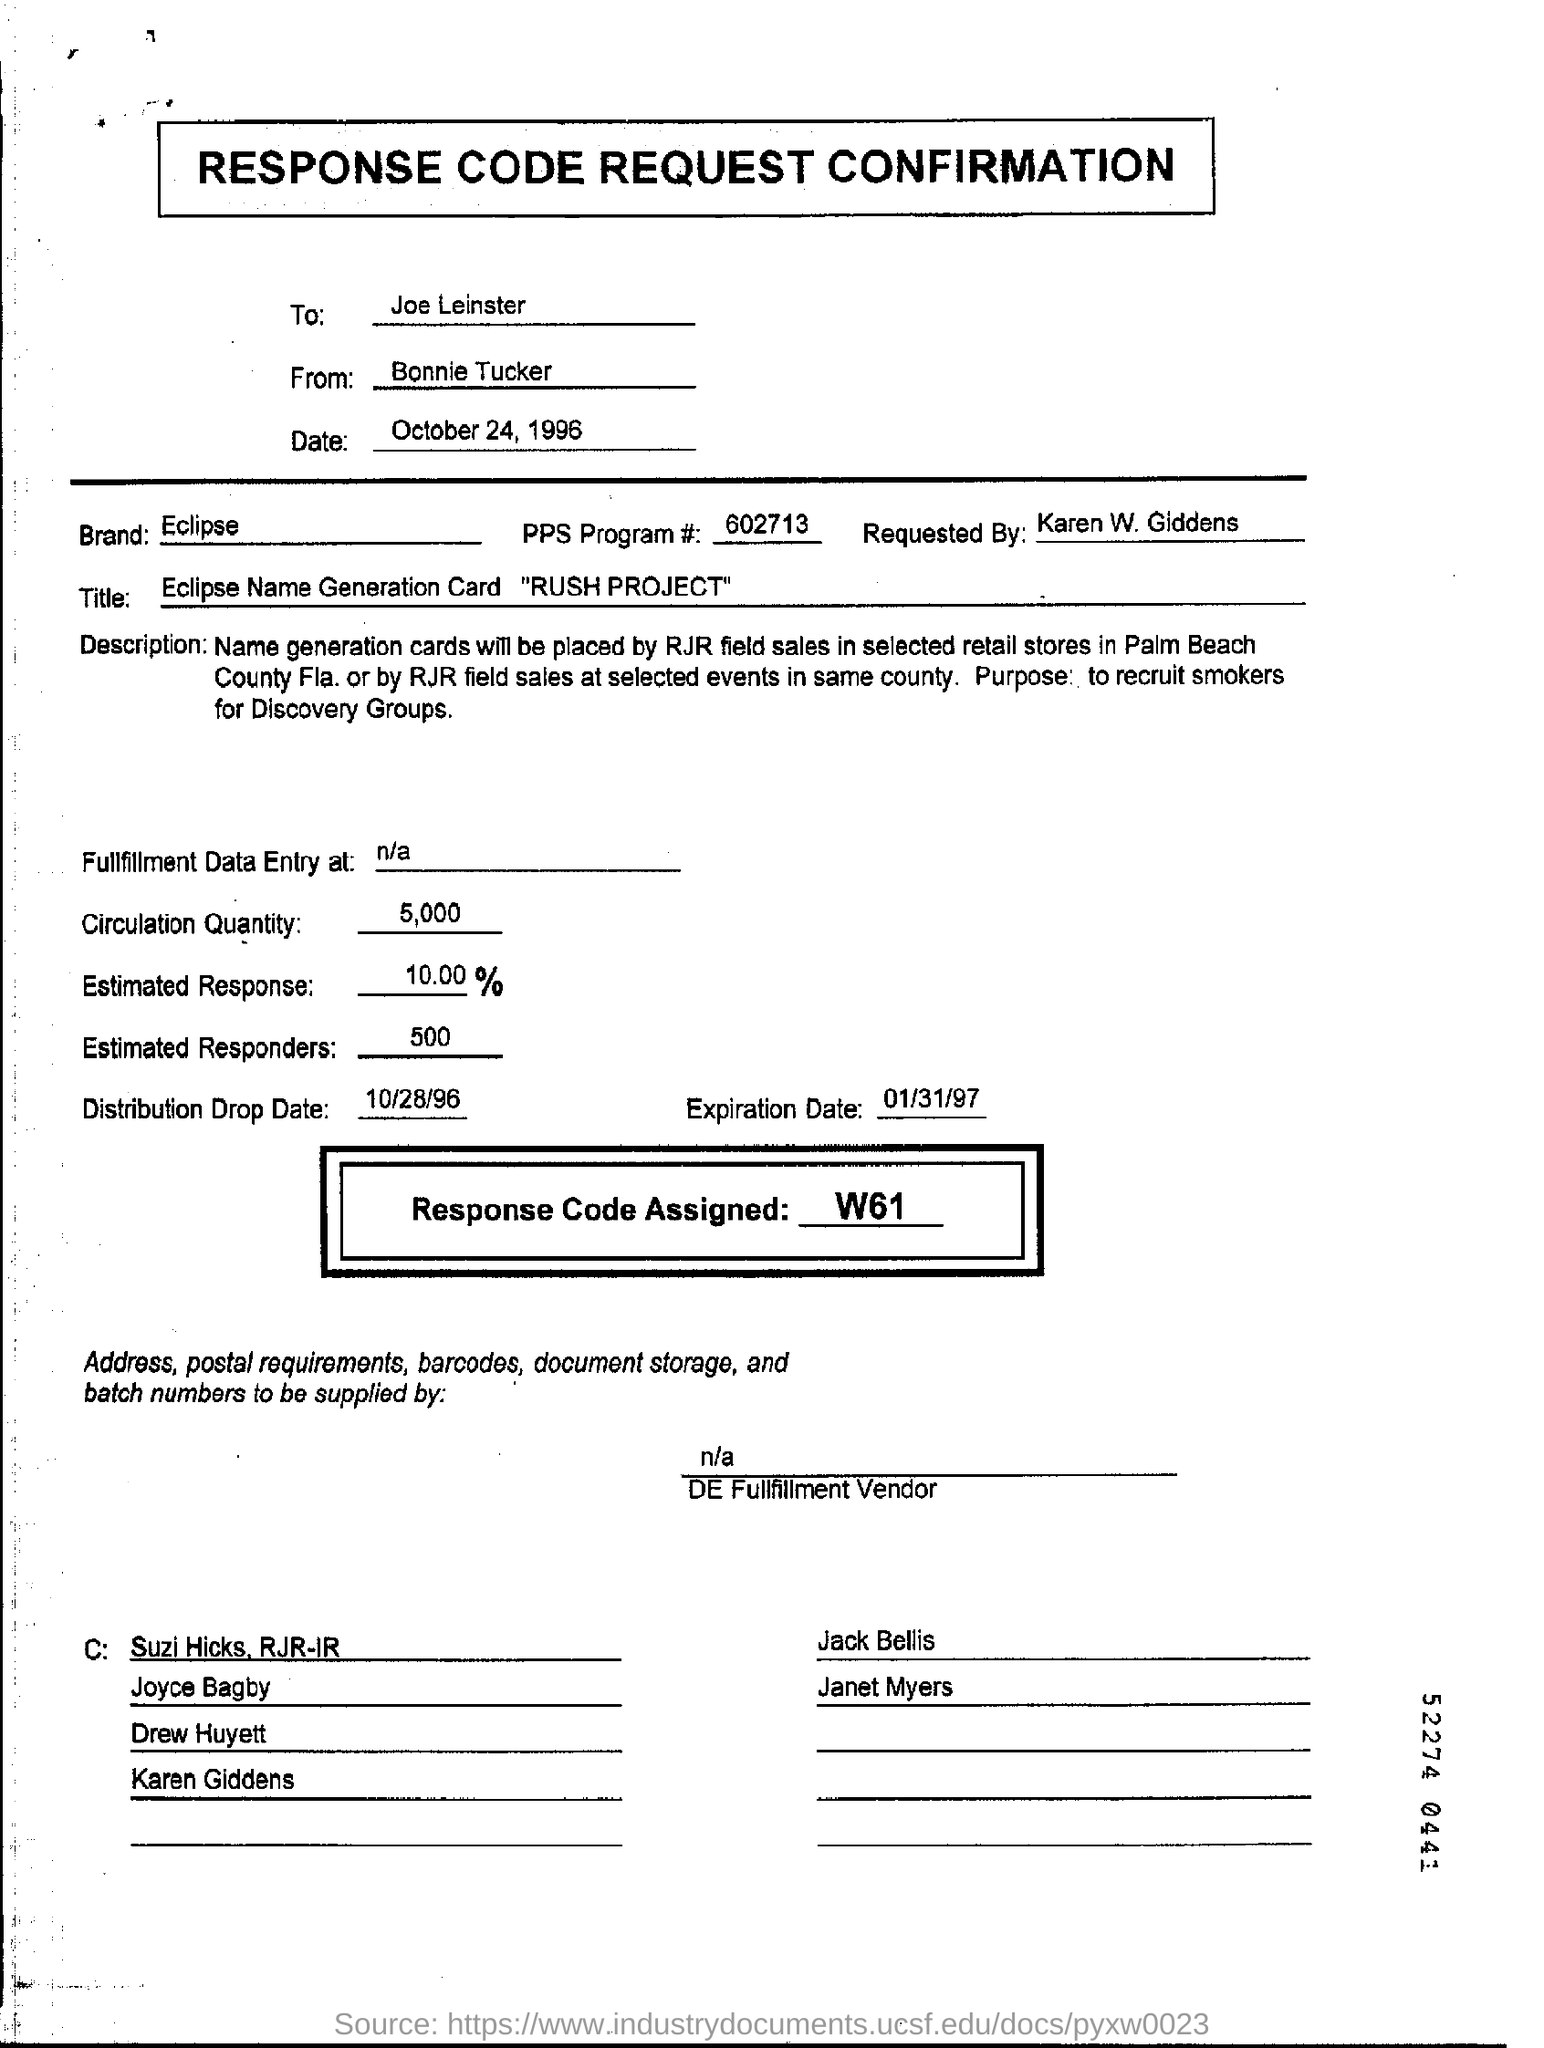List a handful of essential elements in this visual. The document is written by Bonnie Tucker. The date mentioned in the form is October 24, 1996. The response code assigned is W61.. This document is addressed to Joe Leinster. 